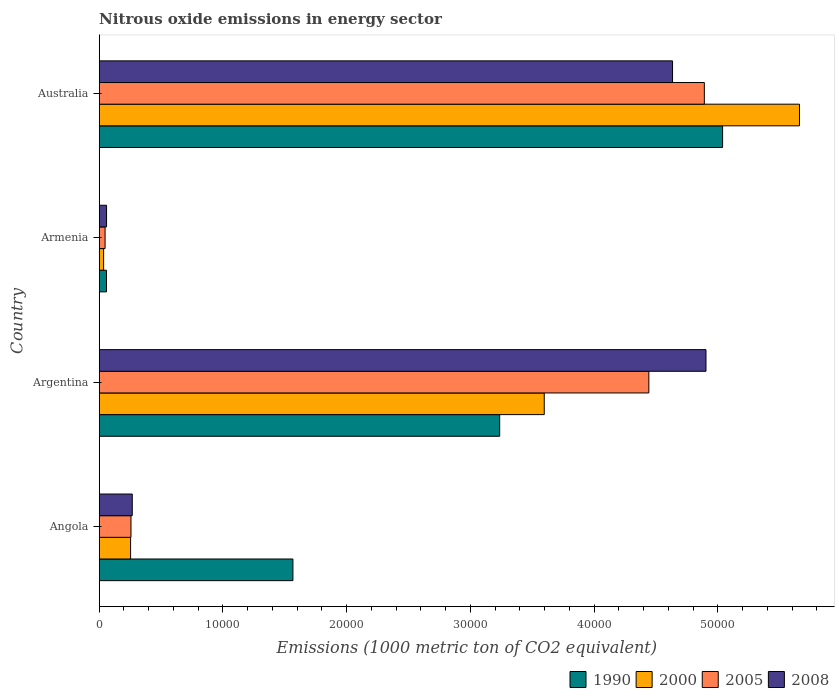How many different coloured bars are there?
Provide a succinct answer. 4. Are the number of bars per tick equal to the number of legend labels?
Provide a succinct answer. Yes. Are the number of bars on each tick of the Y-axis equal?
Provide a short and direct response. Yes. What is the amount of nitrous oxide emitted in 2008 in Argentina?
Provide a short and direct response. 4.90e+04. Across all countries, what is the maximum amount of nitrous oxide emitted in 2008?
Your answer should be very brief. 4.90e+04. Across all countries, what is the minimum amount of nitrous oxide emitted in 2000?
Your response must be concise. 356.1. In which country was the amount of nitrous oxide emitted in 1990 maximum?
Keep it short and to the point. Australia. In which country was the amount of nitrous oxide emitted in 2000 minimum?
Provide a short and direct response. Armenia. What is the total amount of nitrous oxide emitted in 2008 in the graph?
Provide a succinct answer. 9.86e+04. What is the difference between the amount of nitrous oxide emitted in 1990 in Angola and that in Argentina?
Keep it short and to the point. -1.67e+04. What is the difference between the amount of nitrous oxide emitted in 2008 in Argentina and the amount of nitrous oxide emitted in 2005 in Angola?
Make the answer very short. 4.65e+04. What is the average amount of nitrous oxide emitted in 2005 per country?
Offer a terse response. 2.41e+04. What is the difference between the amount of nitrous oxide emitted in 2000 and amount of nitrous oxide emitted in 2008 in Angola?
Your answer should be very brief. -135.1. In how many countries, is the amount of nitrous oxide emitted in 2005 greater than 30000 1000 metric ton?
Offer a very short reply. 2. What is the ratio of the amount of nitrous oxide emitted in 2000 in Angola to that in Argentina?
Your answer should be compact. 0.07. What is the difference between the highest and the second highest amount of nitrous oxide emitted in 1990?
Offer a very short reply. 1.80e+04. What is the difference between the highest and the lowest amount of nitrous oxide emitted in 1990?
Keep it short and to the point. 4.98e+04. In how many countries, is the amount of nitrous oxide emitted in 2008 greater than the average amount of nitrous oxide emitted in 2008 taken over all countries?
Your answer should be compact. 2. Is the sum of the amount of nitrous oxide emitted in 1990 in Argentina and Armenia greater than the maximum amount of nitrous oxide emitted in 2008 across all countries?
Keep it short and to the point. No. Is it the case that in every country, the sum of the amount of nitrous oxide emitted in 2000 and amount of nitrous oxide emitted in 2008 is greater than the sum of amount of nitrous oxide emitted in 1990 and amount of nitrous oxide emitted in 2005?
Your response must be concise. No. What does the 3rd bar from the bottom in Armenia represents?
Give a very brief answer. 2005. Is it the case that in every country, the sum of the amount of nitrous oxide emitted in 2008 and amount of nitrous oxide emitted in 2000 is greater than the amount of nitrous oxide emitted in 1990?
Give a very brief answer. No. How many bars are there?
Provide a succinct answer. 16. Are all the bars in the graph horizontal?
Make the answer very short. Yes. Are the values on the major ticks of X-axis written in scientific E-notation?
Ensure brevity in your answer.  No. Where does the legend appear in the graph?
Keep it short and to the point. Bottom right. How are the legend labels stacked?
Keep it short and to the point. Horizontal. What is the title of the graph?
Keep it short and to the point. Nitrous oxide emissions in energy sector. What is the label or title of the X-axis?
Provide a short and direct response. Emissions (1000 metric ton of CO2 equivalent). What is the Emissions (1000 metric ton of CO2 equivalent) in 1990 in Angola?
Ensure brevity in your answer.  1.57e+04. What is the Emissions (1000 metric ton of CO2 equivalent) of 2000 in Angola?
Offer a very short reply. 2535.2. What is the Emissions (1000 metric ton of CO2 equivalent) of 2005 in Angola?
Give a very brief answer. 2567.4. What is the Emissions (1000 metric ton of CO2 equivalent) in 2008 in Angola?
Provide a succinct answer. 2670.3. What is the Emissions (1000 metric ton of CO2 equivalent) in 1990 in Argentina?
Keep it short and to the point. 3.24e+04. What is the Emissions (1000 metric ton of CO2 equivalent) in 2000 in Argentina?
Offer a terse response. 3.60e+04. What is the Emissions (1000 metric ton of CO2 equivalent) in 2005 in Argentina?
Offer a terse response. 4.44e+04. What is the Emissions (1000 metric ton of CO2 equivalent) of 2008 in Argentina?
Give a very brief answer. 4.90e+04. What is the Emissions (1000 metric ton of CO2 equivalent) in 1990 in Armenia?
Keep it short and to the point. 586.2. What is the Emissions (1000 metric ton of CO2 equivalent) in 2000 in Armenia?
Your response must be concise. 356.1. What is the Emissions (1000 metric ton of CO2 equivalent) of 2005 in Armenia?
Ensure brevity in your answer.  473.3. What is the Emissions (1000 metric ton of CO2 equivalent) of 2008 in Armenia?
Your response must be concise. 593.5. What is the Emissions (1000 metric ton of CO2 equivalent) in 1990 in Australia?
Make the answer very short. 5.04e+04. What is the Emissions (1000 metric ton of CO2 equivalent) of 2000 in Australia?
Ensure brevity in your answer.  5.66e+04. What is the Emissions (1000 metric ton of CO2 equivalent) in 2005 in Australia?
Offer a terse response. 4.89e+04. What is the Emissions (1000 metric ton of CO2 equivalent) in 2008 in Australia?
Offer a terse response. 4.63e+04. Across all countries, what is the maximum Emissions (1000 metric ton of CO2 equivalent) in 1990?
Your response must be concise. 5.04e+04. Across all countries, what is the maximum Emissions (1000 metric ton of CO2 equivalent) in 2000?
Keep it short and to the point. 5.66e+04. Across all countries, what is the maximum Emissions (1000 metric ton of CO2 equivalent) in 2005?
Your answer should be compact. 4.89e+04. Across all countries, what is the maximum Emissions (1000 metric ton of CO2 equivalent) of 2008?
Your response must be concise. 4.90e+04. Across all countries, what is the minimum Emissions (1000 metric ton of CO2 equivalent) of 1990?
Keep it short and to the point. 586.2. Across all countries, what is the minimum Emissions (1000 metric ton of CO2 equivalent) in 2000?
Give a very brief answer. 356.1. Across all countries, what is the minimum Emissions (1000 metric ton of CO2 equivalent) of 2005?
Your response must be concise. 473.3. Across all countries, what is the minimum Emissions (1000 metric ton of CO2 equivalent) in 2008?
Offer a very short reply. 593.5. What is the total Emissions (1000 metric ton of CO2 equivalent) of 1990 in the graph?
Your response must be concise. 9.90e+04. What is the total Emissions (1000 metric ton of CO2 equivalent) in 2000 in the graph?
Ensure brevity in your answer.  9.54e+04. What is the total Emissions (1000 metric ton of CO2 equivalent) in 2005 in the graph?
Offer a terse response. 9.64e+04. What is the total Emissions (1000 metric ton of CO2 equivalent) in 2008 in the graph?
Provide a short and direct response. 9.86e+04. What is the difference between the Emissions (1000 metric ton of CO2 equivalent) in 1990 in Angola and that in Argentina?
Provide a succinct answer. -1.67e+04. What is the difference between the Emissions (1000 metric ton of CO2 equivalent) in 2000 in Angola and that in Argentina?
Give a very brief answer. -3.34e+04. What is the difference between the Emissions (1000 metric ton of CO2 equivalent) of 2005 in Angola and that in Argentina?
Ensure brevity in your answer.  -4.18e+04. What is the difference between the Emissions (1000 metric ton of CO2 equivalent) in 2008 in Angola and that in Argentina?
Ensure brevity in your answer.  -4.64e+04. What is the difference between the Emissions (1000 metric ton of CO2 equivalent) of 1990 in Angola and that in Armenia?
Your answer should be very brief. 1.51e+04. What is the difference between the Emissions (1000 metric ton of CO2 equivalent) in 2000 in Angola and that in Armenia?
Offer a terse response. 2179.1. What is the difference between the Emissions (1000 metric ton of CO2 equivalent) in 2005 in Angola and that in Armenia?
Keep it short and to the point. 2094.1. What is the difference between the Emissions (1000 metric ton of CO2 equivalent) in 2008 in Angola and that in Armenia?
Offer a terse response. 2076.8. What is the difference between the Emissions (1000 metric ton of CO2 equivalent) of 1990 in Angola and that in Australia?
Your answer should be very brief. -3.47e+04. What is the difference between the Emissions (1000 metric ton of CO2 equivalent) of 2000 in Angola and that in Australia?
Provide a short and direct response. -5.41e+04. What is the difference between the Emissions (1000 metric ton of CO2 equivalent) of 2005 in Angola and that in Australia?
Offer a very short reply. -4.63e+04. What is the difference between the Emissions (1000 metric ton of CO2 equivalent) in 2008 in Angola and that in Australia?
Offer a terse response. -4.37e+04. What is the difference between the Emissions (1000 metric ton of CO2 equivalent) of 1990 in Argentina and that in Armenia?
Ensure brevity in your answer.  3.18e+04. What is the difference between the Emissions (1000 metric ton of CO2 equivalent) of 2000 in Argentina and that in Armenia?
Keep it short and to the point. 3.56e+04. What is the difference between the Emissions (1000 metric ton of CO2 equivalent) of 2005 in Argentina and that in Armenia?
Your response must be concise. 4.39e+04. What is the difference between the Emissions (1000 metric ton of CO2 equivalent) in 2008 in Argentina and that in Armenia?
Make the answer very short. 4.84e+04. What is the difference between the Emissions (1000 metric ton of CO2 equivalent) in 1990 in Argentina and that in Australia?
Offer a very short reply. -1.80e+04. What is the difference between the Emissions (1000 metric ton of CO2 equivalent) in 2000 in Argentina and that in Australia?
Ensure brevity in your answer.  -2.06e+04. What is the difference between the Emissions (1000 metric ton of CO2 equivalent) of 2005 in Argentina and that in Australia?
Offer a terse response. -4485.6. What is the difference between the Emissions (1000 metric ton of CO2 equivalent) in 2008 in Argentina and that in Australia?
Ensure brevity in your answer.  2702.4. What is the difference between the Emissions (1000 metric ton of CO2 equivalent) of 1990 in Armenia and that in Australia?
Provide a succinct answer. -4.98e+04. What is the difference between the Emissions (1000 metric ton of CO2 equivalent) of 2000 in Armenia and that in Australia?
Your response must be concise. -5.62e+04. What is the difference between the Emissions (1000 metric ton of CO2 equivalent) of 2005 in Armenia and that in Australia?
Offer a very short reply. -4.84e+04. What is the difference between the Emissions (1000 metric ton of CO2 equivalent) in 2008 in Armenia and that in Australia?
Offer a terse response. -4.57e+04. What is the difference between the Emissions (1000 metric ton of CO2 equivalent) of 1990 in Angola and the Emissions (1000 metric ton of CO2 equivalent) of 2000 in Argentina?
Your response must be concise. -2.03e+04. What is the difference between the Emissions (1000 metric ton of CO2 equivalent) in 1990 in Angola and the Emissions (1000 metric ton of CO2 equivalent) in 2005 in Argentina?
Give a very brief answer. -2.88e+04. What is the difference between the Emissions (1000 metric ton of CO2 equivalent) of 1990 in Angola and the Emissions (1000 metric ton of CO2 equivalent) of 2008 in Argentina?
Provide a short and direct response. -3.34e+04. What is the difference between the Emissions (1000 metric ton of CO2 equivalent) of 2000 in Angola and the Emissions (1000 metric ton of CO2 equivalent) of 2005 in Argentina?
Offer a terse response. -4.19e+04. What is the difference between the Emissions (1000 metric ton of CO2 equivalent) of 2000 in Angola and the Emissions (1000 metric ton of CO2 equivalent) of 2008 in Argentina?
Keep it short and to the point. -4.65e+04. What is the difference between the Emissions (1000 metric ton of CO2 equivalent) in 2005 in Angola and the Emissions (1000 metric ton of CO2 equivalent) in 2008 in Argentina?
Your response must be concise. -4.65e+04. What is the difference between the Emissions (1000 metric ton of CO2 equivalent) in 1990 in Angola and the Emissions (1000 metric ton of CO2 equivalent) in 2000 in Armenia?
Give a very brief answer. 1.53e+04. What is the difference between the Emissions (1000 metric ton of CO2 equivalent) in 1990 in Angola and the Emissions (1000 metric ton of CO2 equivalent) in 2005 in Armenia?
Offer a very short reply. 1.52e+04. What is the difference between the Emissions (1000 metric ton of CO2 equivalent) of 1990 in Angola and the Emissions (1000 metric ton of CO2 equivalent) of 2008 in Armenia?
Ensure brevity in your answer.  1.51e+04. What is the difference between the Emissions (1000 metric ton of CO2 equivalent) in 2000 in Angola and the Emissions (1000 metric ton of CO2 equivalent) in 2005 in Armenia?
Offer a terse response. 2061.9. What is the difference between the Emissions (1000 metric ton of CO2 equivalent) in 2000 in Angola and the Emissions (1000 metric ton of CO2 equivalent) in 2008 in Armenia?
Make the answer very short. 1941.7. What is the difference between the Emissions (1000 metric ton of CO2 equivalent) in 2005 in Angola and the Emissions (1000 metric ton of CO2 equivalent) in 2008 in Armenia?
Offer a very short reply. 1973.9. What is the difference between the Emissions (1000 metric ton of CO2 equivalent) in 1990 in Angola and the Emissions (1000 metric ton of CO2 equivalent) in 2000 in Australia?
Offer a very short reply. -4.09e+04. What is the difference between the Emissions (1000 metric ton of CO2 equivalent) in 1990 in Angola and the Emissions (1000 metric ton of CO2 equivalent) in 2005 in Australia?
Make the answer very short. -3.32e+04. What is the difference between the Emissions (1000 metric ton of CO2 equivalent) in 1990 in Angola and the Emissions (1000 metric ton of CO2 equivalent) in 2008 in Australia?
Offer a very short reply. -3.07e+04. What is the difference between the Emissions (1000 metric ton of CO2 equivalent) of 2000 in Angola and the Emissions (1000 metric ton of CO2 equivalent) of 2005 in Australia?
Offer a very short reply. -4.64e+04. What is the difference between the Emissions (1000 metric ton of CO2 equivalent) of 2000 in Angola and the Emissions (1000 metric ton of CO2 equivalent) of 2008 in Australia?
Your response must be concise. -4.38e+04. What is the difference between the Emissions (1000 metric ton of CO2 equivalent) in 2005 in Angola and the Emissions (1000 metric ton of CO2 equivalent) in 2008 in Australia?
Provide a short and direct response. -4.38e+04. What is the difference between the Emissions (1000 metric ton of CO2 equivalent) of 1990 in Argentina and the Emissions (1000 metric ton of CO2 equivalent) of 2000 in Armenia?
Provide a short and direct response. 3.20e+04. What is the difference between the Emissions (1000 metric ton of CO2 equivalent) of 1990 in Argentina and the Emissions (1000 metric ton of CO2 equivalent) of 2005 in Armenia?
Ensure brevity in your answer.  3.19e+04. What is the difference between the Emissions (1000 metric ton of CO2 equivalent) in 1990 in Argentina and the Emissions (1000 metric ton of CO2 equivalent) in 2008 in Armenia?
Provide a short and direct response. 3.18e+04. What is the difference between the Emissions (1000 metric ton of CO2 equivalent) of 2000 in Argentina and the Emissions (1000 metric ton of CO2 equivalent) of 2005 in Armenia?
Your response must be concise. 3.55e+04. What is the difference between the Emissions (1000 metric ton of CO2 equivalent) in 2000 in Argentina and the Emissions (1000 metric ton of CO2 equivalent) in 2008 in Armenia?
Provide a succinct answer. 3.54e+04. What is the difference between the Emissions (1000 metric ton of CO2 equivalent) of 2005 in Argentina and the Emissions (1000 metric ton of CO2 equivalent) of 2008 in Armenia?
Provide a succinct answer. 4.38e+04. What is the difference between the Emissions (1000 metric ton of CO2 equivalent) in 1990 in Argentina and the Emissions (1000 metric ton of CO2 equivalent) in 2000 in Australia?
Provide a short and direct response. -2.42e+04. What is the difference between the Emissions (1000 metric ton of CO2 equivalent) of 1990 in Argentina and the Emissions (1000 metric ton of CO2 equivalent) of 2005 in Australia?
Provide a short and direct response. -1.65e+04. What is the difference between the Emissions (1000 metric ton of CO2 equivalent) in 1990 in Argentina and the Emissions (1000 metric ton of CO2 equivalent) in 2008 in Australia?
Offer a very short reply. -1.40e+04. What is the difference between the Emissions (1000 metric ton of CO2 equivalent) of 2000 in Argentina and the Emissions (1000 metric ton of CO2 equivalent) of 2005 in Australia?
Your response must be concise. -1.29e+04. What is the difference between the Emissions (1000 metric ton of CO2 equivalent) of 2000 in Argentina and the Emissions (1000 metric ton of CO2 equivalent) of 2008 in Australia?
Provide a short and direct response. -1.04e+04. What is the difference between the Emissions (1000 metric ton of CO2 equivalent) of 2005 in Argentina and the Emissions (1000 metric ton of CO2 equivalent) of 2008 in Australia?
Provide a succinct answer. -1915.3. What is the difference between the Emissions (1000 metric ton of CO2 equivalent) of 1990 in Armenia and the Emissions (1000 metric ton of CO2 equivalent) of 2000 in Australia?
Give a very brief answer. -5.60e+04. What is the difference between the Emissions (1000 metric ton of CO2 equivalent) of 1990 in Armenia and the Emissions (1000 metric ton of CO2 equivalent) of 2005 in Australia?
Your answer should be compact. -4.83e+04. What is the difference between the Emissions (1000 metric ton of CO2 equivalent) in 1990 in Armenia and the Emissions (1000 metric ton of CO2 equivalent) in 2008 in Australia?
Give a very brief answer. -4.57e+04. What is the difference between the Emissions (1000 metric ton of CO2 equivalent) of 2000 in Armenia and the Emissions (1000 metric ton of CO2 equivalent) of 2005 in Australia?
Your answer should be compact. -4.85e+04. What is the difference between the Emissions (1000 metric ton of CO2 equivalent) of 2000 in Armenia and the Emissions (1000 metric ton of CO2 equivalent) of 2008 in Australia?
Give a very brief answer. -4.60e+04. What is the difference between the Emissions (1000 metric ton of CO2 equivalent) of 2005 in Armenia and the Emissions (1000 metric ton of CO2 equivalent) of 2008 in Australia?
Give a very brief answer. -4.59e+04. What is the average Emissions (1000 metric ton of CO2 equivalent) of 1990 per country?
Your answer should be compact. 2.47e+04. What is the average Emissions (1000 metric ton of CO2 equivalent) in 2000 per country?
Keep it short and to the point. 2.39e+04. What is the average Emissions (1000 metric ton of CO2 equivalent) in 2005 per country?
Offer a terse response. 2.41e+04. What is the average Emissions (1000 metric ton of CO2 equivalent) in 2008 per country?
Offer a terse response. 2.47e+04. What is the difference between the Emissions (1000 metric ton of CO2 equivalent) of 1990 and Emissions (1000 metric ton of CO2 equivalent) of 2000 in Angola?
Offer a very short reply. 1.31e+04. What is the difference between the Emissions (1000 metric ton of CO2 equivalent) of 1990 and Emissions (1000 metric ton of CO2 equivalent) of 2005 in Angola?
Your answer should be compact. 1.31e+04. What is the difference between the Emissions (1000 metric ton of CO2 equivalent) of 1990 and Emissions (1000 metric ton of CO2 equivalent) of 2008 in Angola?
Give a very brief answer. 1.30e+04. What is the difference between the Emissions (1000 metric ton of CO2 equivalent) in 2000 and Emissions (1000 metric ton of CO2 equivalent) in 2005 in Angola?
Provide a succinct answer. -32.2. What is the difference between the Emissions (1000 metric ton of CO2 equivalent) of 2000 and Emissions (1000 metric ton of CO2 equivalent) of 2008 in Angola?
Your answer should be very brief. -135.1. What is the difference between the Emissions (1000 metric ton of CO2 equivalent) in 2005 and Emissions (1000 metric ton of CO2 equivalent) in 2008 in Angola?
Your response must be concise. -102.9. What is the difference between the Emissions (1000 metric ton of CO2 equivalent) of 1990 and Emissions (1000 metric ton of CO2 equivalent) of 2000 in Argentina?
Keep it short and to the point. -3600.5. What is the difference between the Emissions (1000 metric ton of CO2 equivalent) in 1990 and Emissions (1000 metric ton of CO2 equivalent) in 2005 in Argentina?
Make the answer very short. -1.21e+04. What is the difference between the Emissions (1000 metric ton of CO2 equivalent) in 1990 and Emissions (1000 metric ton of CO2 equivalent) in 2008 in Argentina?
Your answer should be compact. -1.67e+04. What is the difference between the Emissions (1000 metric ton of CO2 equivalent) in 2000 and Emissions (1000 metric ton of CO2 equivalent) in 2005 in Argentina?
Your answer should be very brief. -8453.1. What is the difference between the Emissions (1000 metric ton of CO2 equivalent) in 2000 and Emissions (1000 metric ton of CO2 equivalent) in 2008 in Argentina?
Offer a very short reply. -1.31e+04. What is the difference between the Emissions (1000 metric ton of CO2 equivalent) of 2005 and Emissions (1000 metric ton of CO2 equivalent) of 2008 in Argentina?
Offer a terse response. -4617.7. What is the difference between the Emissions (1000 metric ton of CO2 equivalent) of 1990 and Emissions (1000 metric ton of CO2 equivalent) of 2000 in Armenia?
Provide a short and direct response. 230.1. What is the difference between the Emissions (1000 metric ton of CO2 equivalent) in 1990 and Emissions (1000 metric ton of CO2 equivalent) in 2005 in Armenia?
Your answer should be compact. 112.9. What is the difference between the Emissions (1000 metric ton of CO2 equivalent) in 1990 and Emissions (1000 metric ton of CO2 equivalent) in 2008 in Armenia?
Provide a short and direct response. -7.3. What is the difference between the Emissions (1000 metric ton of CO2 equivalent) of 2000 and Emissions (1000 metric ton of CO2 equivalent) of 2005 in Armenia?
Offer a terse response. -117.2. What is the difference between the Emissions (1000 metric ton of CO2 equivalent) of 2000 and Emissions (1000 metric ton of CO2 equivalent) of 2008 in Armenia?
Your answer should be compact. -237.4. What is the difference between the Emissions (1000 metric ton of CO2 equivalent) in 2005 and Emissions (1000 metric ton of CO2 equivalent) in 2008 in Armenia?
Give a very brief answer. -120.2. What is the difference between the Emissions (1000 metric ton of CO2 equivalent) of 1990 and Emissions (1000 metric ton of CO2 equivalent) of 2000 in Australia?
Give a very brief answer. -6212.8. What is the difference between the Emissions (1000 metric ton of CO2 equivalent) in 1990 and Emissions (1000 metric ton of CO2 equivalent) in 2005 in Australia?
Ensure brevity in your answer.  1475.2. What is the difference between the Emissions (1000 metric ton of CO2 equivalent) of 1990 and Emissions (1000 metric ton of CO2 equivalent) of 2008 in Australia?
Make the answer very short. 4045.5. What is the difference between the Emissions (1000 metric ton of CO2 equivalent) of 2000 and Emissions (1000 metric ton of CO2 equivalent) of 2005 in Australia?
Offer a terse response. 7688. What is the difference between the Emissions (1000 metric ton of CO2 equivalent) of 2000 and Emissions (1000 metric ton of CO2 equivalent) of 2008 in Australia?
Provide a succinct answer. 1.03e+04. What is the difference between the Emissions (1000 metric ton of CO2 equivalent) of 2005 and Emissions (1000 metric ton of CO2 equivalent) of 2008 in Australia?
Offer a terse response. 2570.3. What is the ratio of the Emissions (1000 metric ton of CO2 equivalent) in 1990 in Angola to that in Argentina?
Give a very brief answer. 0.48. What is the ratio of the Emissions (1000 metric ton of CO2 equivalent) of 2000 in Angola to that in Argentina?
Keep it short and to the point. 0.07. What is the ratio of the Emissions (1000 metric ton of CO2 equivalent) of 2005 in Angola to that in Argentina?
Your answer should be very brief. 0.06. What is the ratio of the Emissions (1000 metric ton of CO2 equivalent) in 2008 in Angola to that in Argentina?
Keep it short and to the point. 0.05. What is the ratio of the Emissions (1000 metric ton of CO2 equivalent) in 1990 in Angola to that in Armenia?
Give a very brief answer. 26.7. What is the ratio of the Emissions (1000 metric ton of CO2 equivalent) in 2000 in Angola to that in Armenia?
Your answer should be very brief. 7.12. What is the ratio of the Emissions (1000 metric ton of CO2 equivalent) of 2005 in Angola to that in Armenia?
Your answer should be compact. 5.42. What is the ratio of the Emissions (1000 metric ton of CO2 equivalent) of 2008 in Angola to that in Armenia?
Make the answer very short. 4.5. What is the ratio of the Emissions (1000 metric ton of CO2 equivalent) of 1990 in Angola to that in Australia?
Offer a very short reply. 0.31. What is the ratio of the Emissions (1000 metric ton of CO2 equivalent) in 2000 in Angola to that in Australia?
Your answer should be very brief. 0.04. What is the ratio of the Emissions (1000 metric ton of CO2 equivalent) of 2005 in Angola to that in Australia?
Your response must be concise. 0.05. What is the ratio of the Emissions (1000 metric ton of CO2 equivalent) in 2008 in Angola to that in Australia?
Offer a terse response. 0.06. What is the ratio of the Emissions (1000 metric ton of CO2 equivalent) in 1990 in Argentina to that in Armenia?
Your response must be concise. 55.21. What is the ratio of the Emissions (1000 metric ton of CO2 equivalent) of 2000 in Argentina to that in Armenia?
Provide a short and direct response. 100.99. What is the ratio of the Emissions (1000 metric ton of CO2 equivalent) of 2005 in Argentina to that in Armenia?
Make the answer very short. 93.85. What is the ratio of the Emissions (1000 metric ton of CO2 equivalent) of 2008 in Argentina to that in Armenia?
Your answer should be compact. 82.62. What is the ratio of the Emissions (1000 metric ton of CO2 equivalent) of 1990 in Argentina to that in Australia?
Keep it short and to the point. 0.64. What is the ratio of the Emissions (1000 metric ton of CO2 equivalent) of 2000 in Argentina to that in Australia?
Make the answer very short. 0.64. What is the ratio of the Emissions (1000 metric ton of CO2 equivalent) of 2005 in Argentina to that in Australia?
Provide a short and direct response. 0.91. What is the ratio of the Emissions (1000 metric ton of CO2 equivalent) in 2008 in Argentina to that in Australia?
Your answer should be compact. 1.06. What is the ratio of the Emissions (1000 metric ton of CO2 equivalent) in 1990 in Armenia to that in Australia?
Make the answer very short. 0.01. What is the ratio of the Emissions (1000 metric ton of CO2 equivalent) of 2000 in Armenia to that in Australia?
Offer a very short reply. 0.01. What is the ratio of the Emissions (1000 metric ton of CO2 equivalent) in 2005 in Armenia to that in Australia?
Provide a short and direct response. 0.01. What is the ratio of the Emissions (1000 metric ton of CO2 equivalent) in 2008 in Armenia to that in Australia?
Your response must be concise. 0.01. What is the difference between the highest and the second highest Emissions (1000 metric ton of CO2 equivalent) in 1990?
Your response must be concise. 1.80e+04. What is the difference between the highest and the second highest Emissions (1000 metric ton of CO2 equivalent) in 2000?
Your answer should be very brief. 2.06e+04. What is the difference between the highest and the second highest Emissions (1000 metric ton of CO2 equivalent) of 2005?
Give a very brief answer. 4485.6. What is the difference between the highest and the second highest Emissions (1000 metric ton of CO2 equivalent) of 2008?
Your response must be concise. 2702.4. What is the difference between the highest and the lowest Emissions (1000 metric ton of CO2 equivalent) in 1990?
Make the answer very short. 4.98e+04. What is the difference between the highest and the lowest Emissions (1000 metric ton of CO2 equivalent) of 2000?
Your answer should be compact. 5.62e+04. What is the difference between the highest and the lowest Emissions (1000 metric ton of CO2 equivalent) of 2005?
Ensure brevity in your answer.  4.84e+04. What is the difference between the highest and the lowest Emissions (1000 metric ton of CO2 equivalent) in 2008?
Your response must be concise. 4.84e+04. 